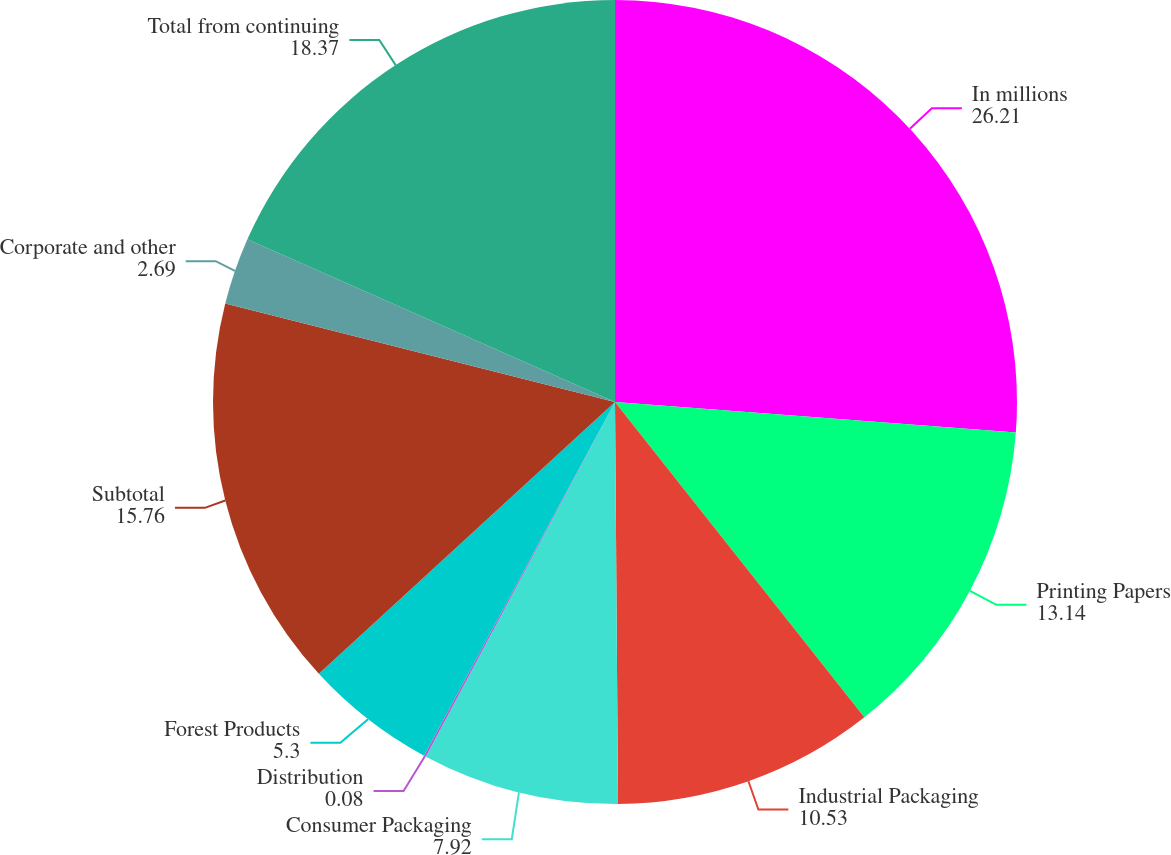<chart> <loc_0><loc_0><loc_500><loc_500><pie_chart><fcel>In millions<fcel>Printing Papers<fcel>Industrial Packaging<fcel>Consumer Packaging<fcel>Distribution<fcel>Forest Products<fcel>Subtotal<fcel>Corporate and other<fcel>Total from continuing<nl><fcel>26.21%<fcel>13.14%<fcel>10.53%<fcel>7.92%<fcel>0.08%<fcel>5.3%<fcel>15.76%<fcel>2.69%<fcel>18.37%<nl></chart> 